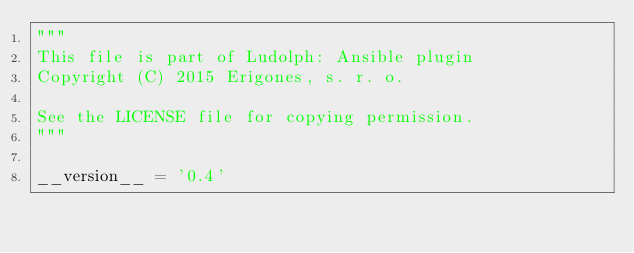<code> <loc_0><loc_0><loc_500><loc_500><_Python_>"""
This file is part of Ludolph: Ansible plugin
Copyright (C) 2015 Erigones, s. r. o.

See the LICENSE file for copying permission.
"""

__version__ = '0.4'
</code> 